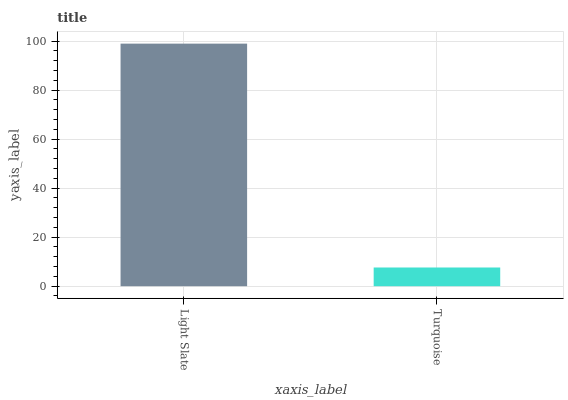Is Turquoise the minimum?
Answer yes or no. Yes. Is Light Slate the maximum?
Answer yes or no. Yes. Is Turquoise the maximum?
Answer yes or no. No. Is Light Slate greater than Turquoise?
Answer yes or no. Yes. Is Turquoise less than Light Slate?
Answer yes or no. Yes. Is Turquoise greater than Light Slate?
Answer yes or no. No. Is Light Slate less than Turquoise?
Answer yes or no. No. Is Light Slate the high median?
Answer yes or no. Yes. Is Turquoise the low median?
Answer yes or no. Yes. Is Turquoise the high median?
Answer yes or no. No. Is Light Slate the low median?
Answer yes or no. No. 